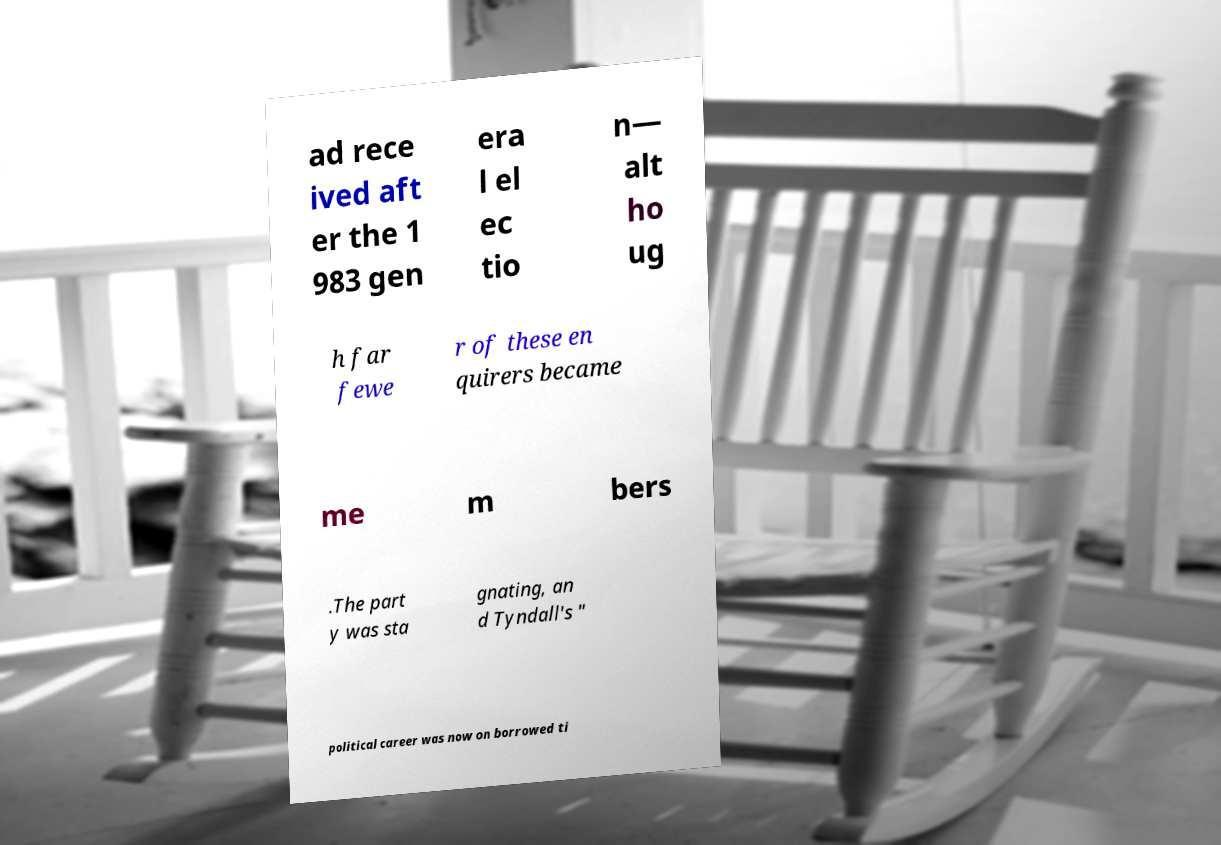For documentation purposes, I need the text within this image transcribed. Could you provide that? ad rece ived aft er the 1 983 gen era l el ec tio n— alt ho ug h far fewe r of these en quirers became me m bers .The part y was sta gnating, an d Tyndall's " political career was now on borrowed ti 